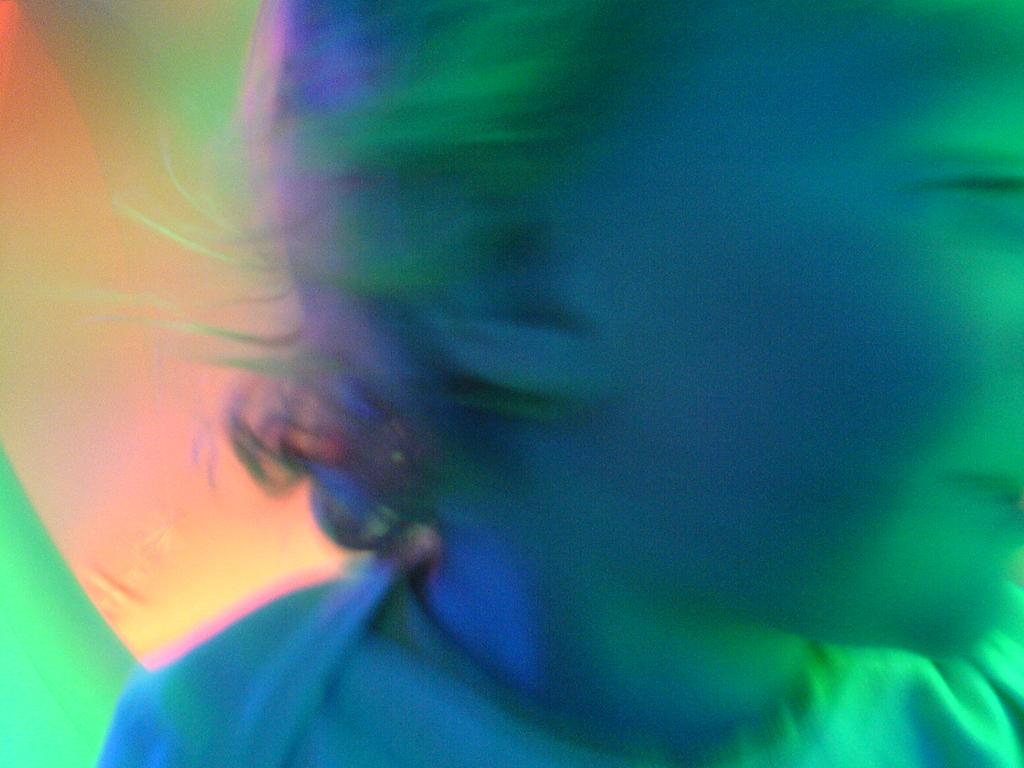What is the main subject of the image? The main subject of the image is a kid. What can be seen on the left side of the image? There are green and orange lights on the left side of the image. What type of crate is visible in the image? There is no crate present in the image. What kind of pipe can be seen in the image? There is no pipe present in the image. Is there a plane visible in the image? There is no plane present in the image. 